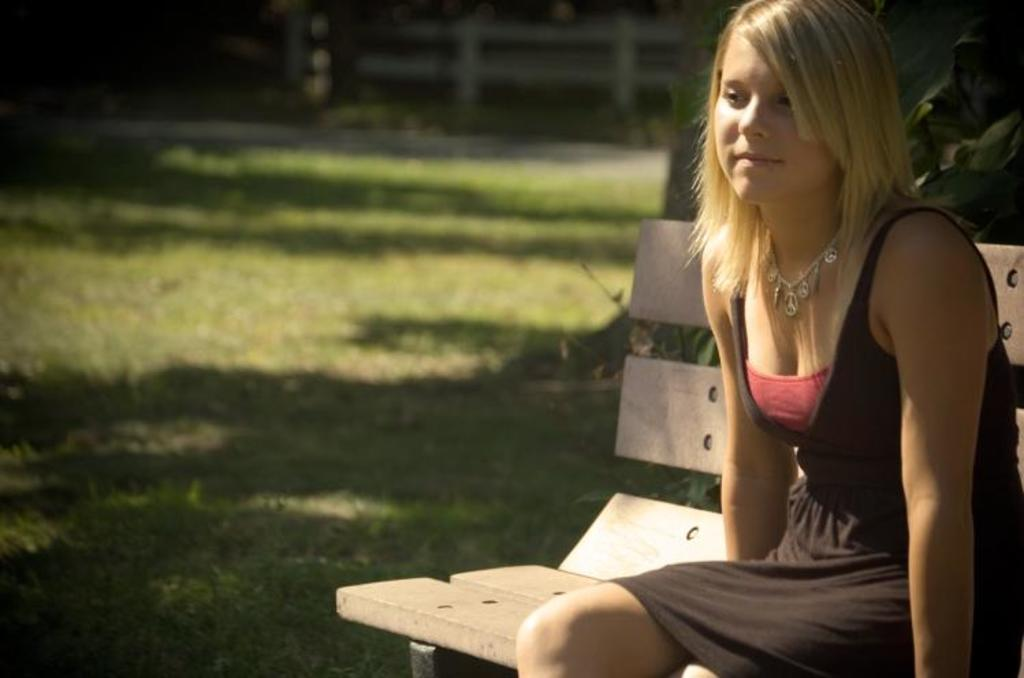Who is present in the image? There is a woman in the image. What is the woman doing in the image? The woman is sitting on a bench. Where is the bench located? The bench is located in a garden. What flavor of ice cream is the woman holding in the image? There is no ice cream present in the image; the woman is sitting on a bench in a garden. 